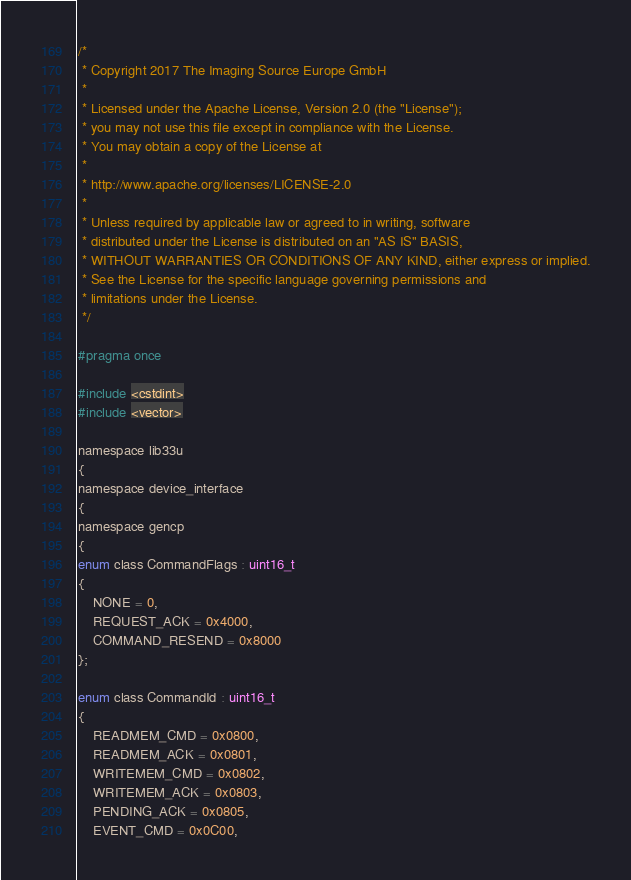Convert code to text. <code><loc_0><loc_0><loc_500><loc_500><_C_>/*
 * Copyright 2017 The Imaging Source Europe GmbH
 *
 * Licensed under the Apache License, Version 2.0 (the "License");
 * you may not use this file except in compliance with the License.
 * You may obtain a copy of the License at
 *
 * http://www.apache.org/licenses/LICENSE-2.0
 *
 * Unless required by applicable law or agreed to in writing, software
 * distributed under the License is distributed on an "AS IS" BASIS,
 * WITHOUT WARRANTIES OR CONDITIONS OF ANY KIND, either express or implied.
 * See the License for the specific language governing permissions and
 * limitations under the License.
 */

#pragma once

#include <cstdint>
#include <vector>

namespace lib33u
{
namespace device_interface
{
namespace gencp
{
enum class CommandFlags : uint16_t
{
    NONE = 0,
    REQUEST_ACK = 0x4000,
    COMMAND_RESEND = 0x8000
};

enum class CommandId : uint16_t
{
    READMEM_CMD = 0x0800,
    READMEM_ACK = 0x0801,
    WRITEMEM_CMD = 0x0802,
    WRITEMEM_ACK = 0x0803,
    PENDING_ACK = 0x0805,
    EVENT_CMD = 0x0C00,</code> 